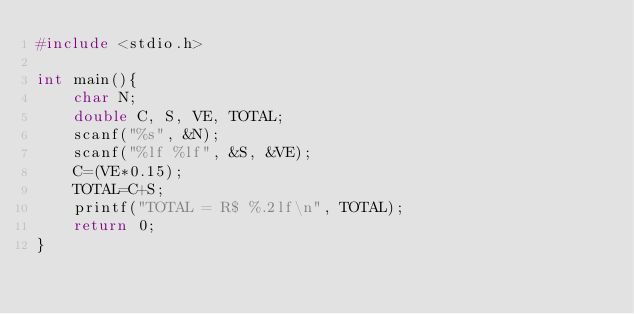<code> <loc_0><loc_0><loc_500><loc_500><_C_>#include <stdio.h>

int main(){
    char N;
    double C, S, VE, TOTAL;
    scanf("%s", &N);
    scanf("%lf %lf", &S, &VE);
    C=(VE*0.15);
    TOTAL=C+S;
    printf("TOTAL = R$ %.2lf\n", TOTAL);
    return 0;
}
</code> 